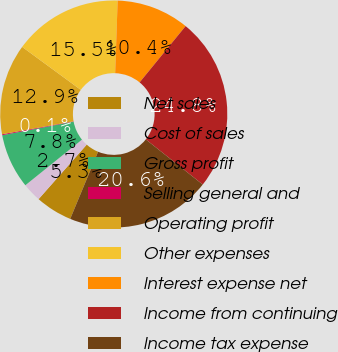Convert chart to OTSL. <chart><loc_0><loc_0><loc_500><loc_500><pie_chart><fcel>Net sales<fcel>Cost of sales<fcel>Gross profit<fcel>Selling general and<fcel>Operating profit<fcel>Other expenses<fcel>Interest expense net<fcel>Income from continuing<fcel>Income tax expense<nl><fcel>5.25%<fcel>2.69%<fcel>7.81%<fcel>0.13%<fcel>12.92%<fcel>15.48%<fcel>10.36%<fcel>24.76%<fcel>20.6%<nl></chart> 